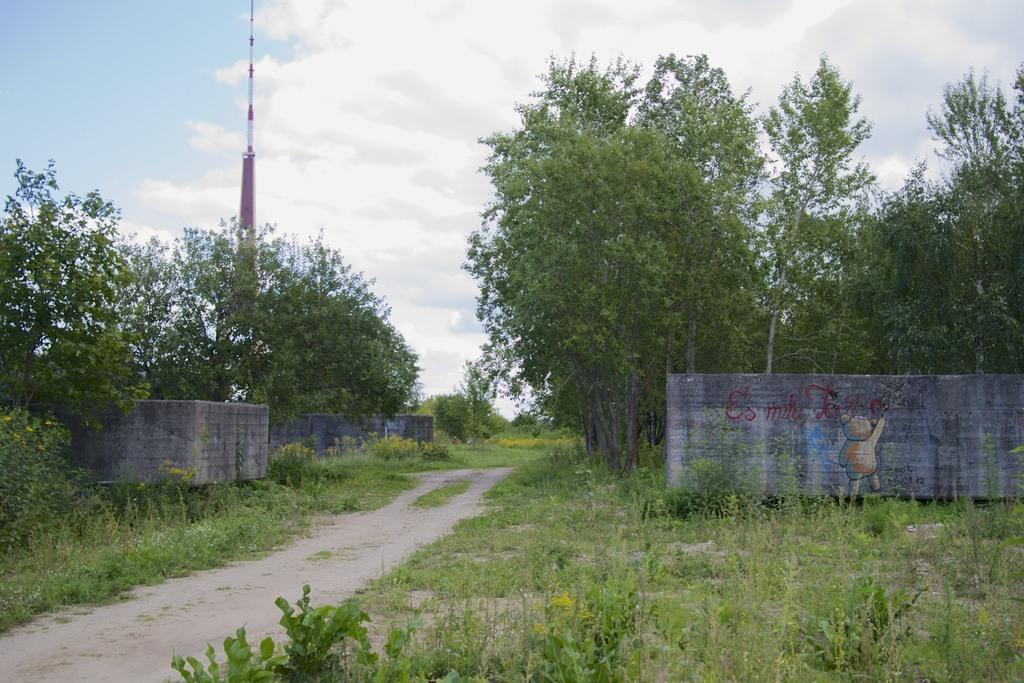What type of vegetation can be seen in the image? There are trees and plants in the image. What structure is present in the image? There is a pole in the image. What can be seen in the background of the image? The sky is visible in the background of the image. What type of field is visible in the image? There is no field visible in the image; it features trees, plants, a pole, and the sky. How many planes can be seen flying in the image? There are no planes present in the image. 